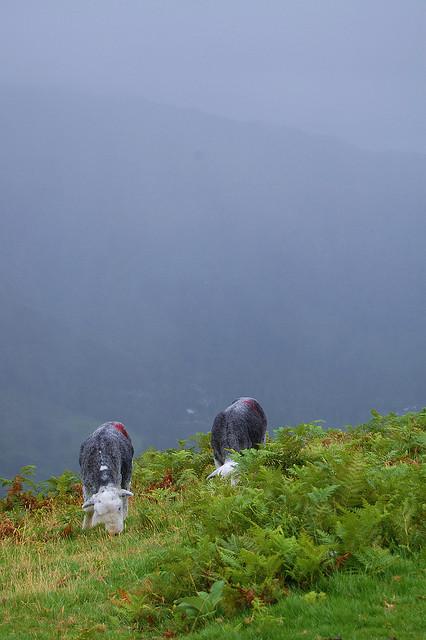Is it a gloomy day?
Be succinct. Yes. Are there mountains in this picture?
Short answer required. Yes. What are the cattle doing?
Short answer required. Grazing. 